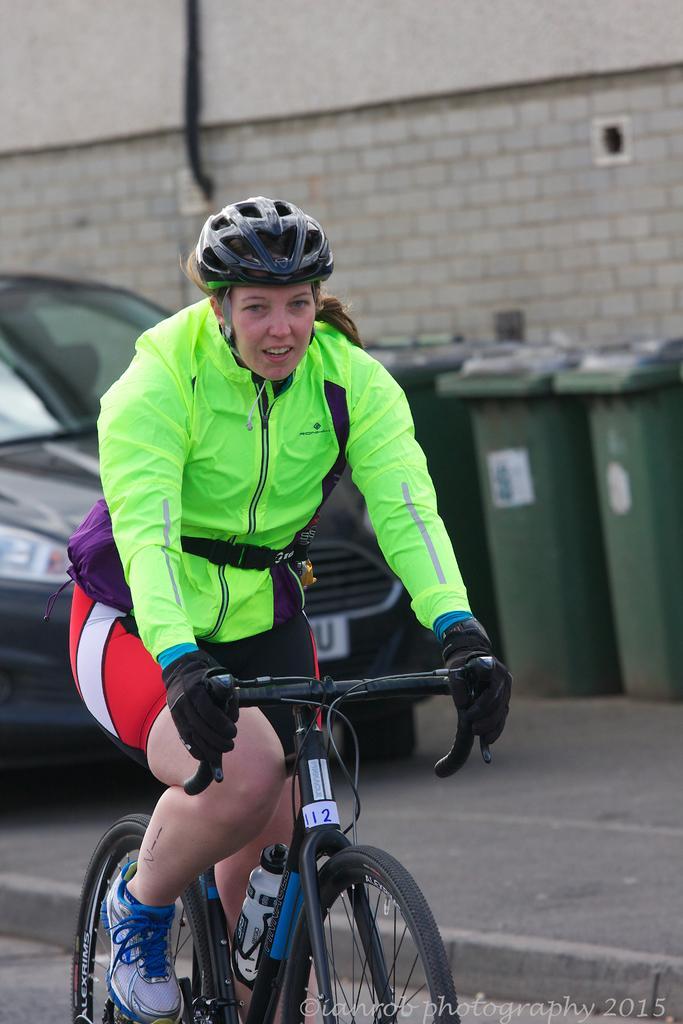How would you summarize this image in a sentence or two? In the middle there is a woman ,she is riding bicycle ,she wear green jacket ,trouser ,shoes and helmet. In the back ground there is a car ,three dustbins and wall. 